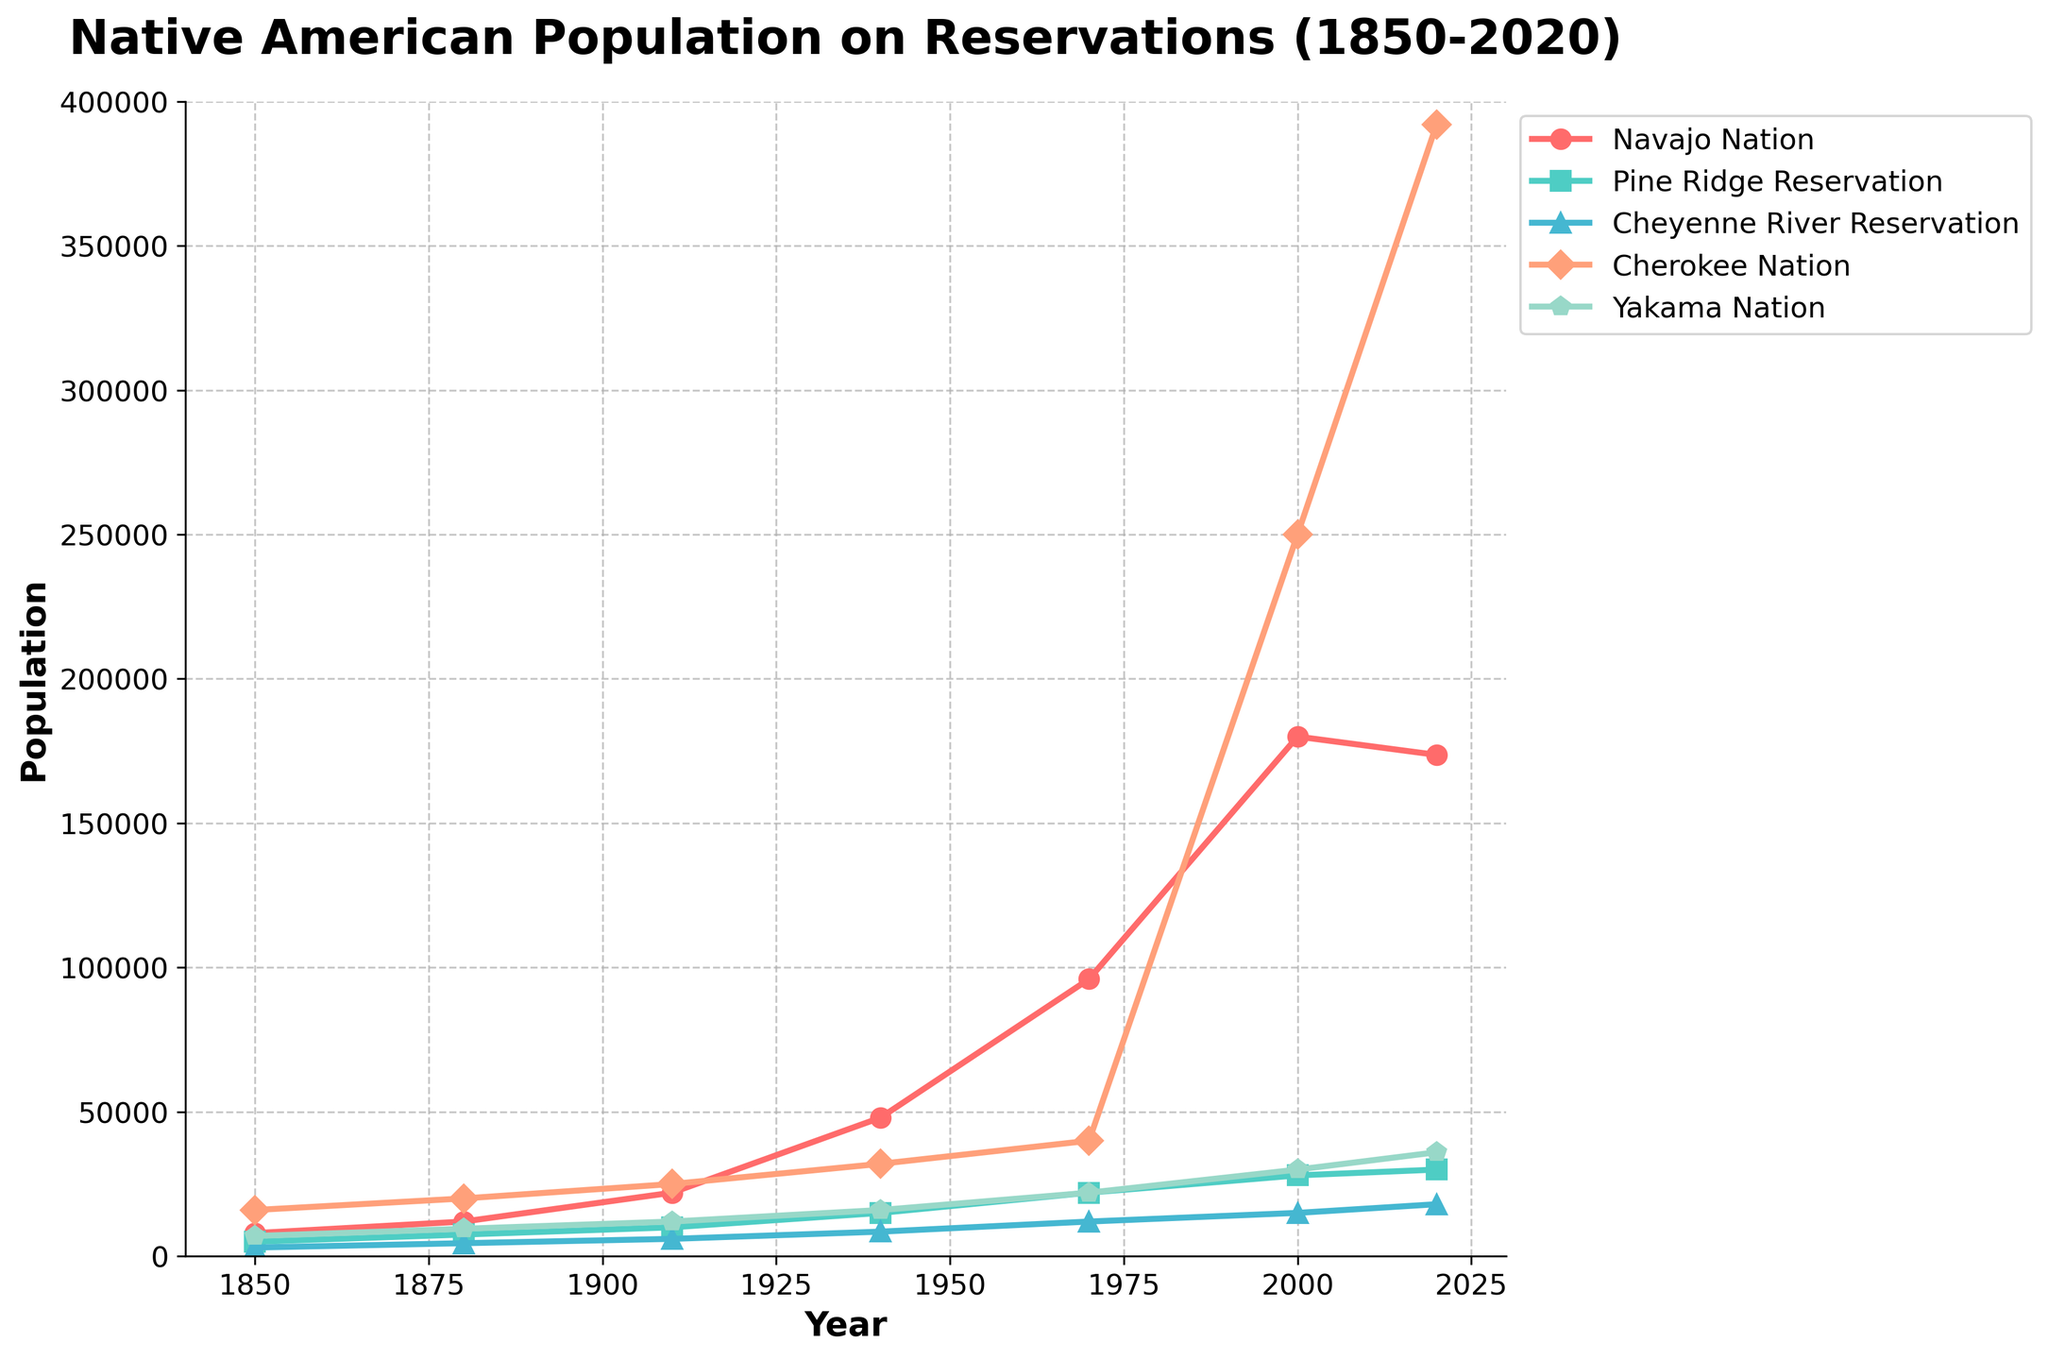Which reservation had the largest population growth from 1850 to 2020? To find the reservation with the largest population growth, subtract the 1850 population from the 2020 population for each reservation. The changes are as follows: Navajo Nation (173667 - 8000 = 165667), Pine Ridge Reservation (30000 - 5000 = 25000), Cheyenne River Reservation (18000 - 3000 = 15000), Cherokee Nation (392000 - 16000 = 376000), Yakama Nation (36000 - 7000 = 29000). The Cherokee Nation had the largest population growth.
Answer: Cherokee Nation Which reservation had a population decrease between 2000 and 2020? Compare the population in 2000 and 2020 for each reservation. Navajo Nation decreased from 180000 to 173667, while the other reservations increased. So, the Navajo Nation had a population decrease between 2000 and 2020.
Answer: Navajo Nation What was the total population of the Cheyenne River Reservation and Pine Ridge Reservation in 1880? Add the populations of the Cheyenne River Reservation and Pine Ridge Reservation in 1880: 4500 (Cheyenne River Reservation) + 7500 (Pine Ridge Reservation) = 12000.
Answer: 12000 Between which two consecutive periods did the Cherokee Nation see the largest increase in population? Calculate the population increase for each period: 1850-1880 (4000), 1880-1910 (5000), 1910-1940 (7000), 1940-1970 (8000), 1970-2000 (210000), 2000-2020 (142000). The largest increase is between 1970 and 2000.
Answer: 1970 to 2000 Which reservation had the smallest population in 1940? Compare the populations of each reservation in 1940: Navajo Nation (48000), Pine Ridge Reservation (15000), Cheyenne River Reservation (8500), Cherokee Nation (32000), Yakama Nation (16000). The Cheyenne River Reservation had the smallest population in 1940.
Answer: Cheyenne River Reservation 